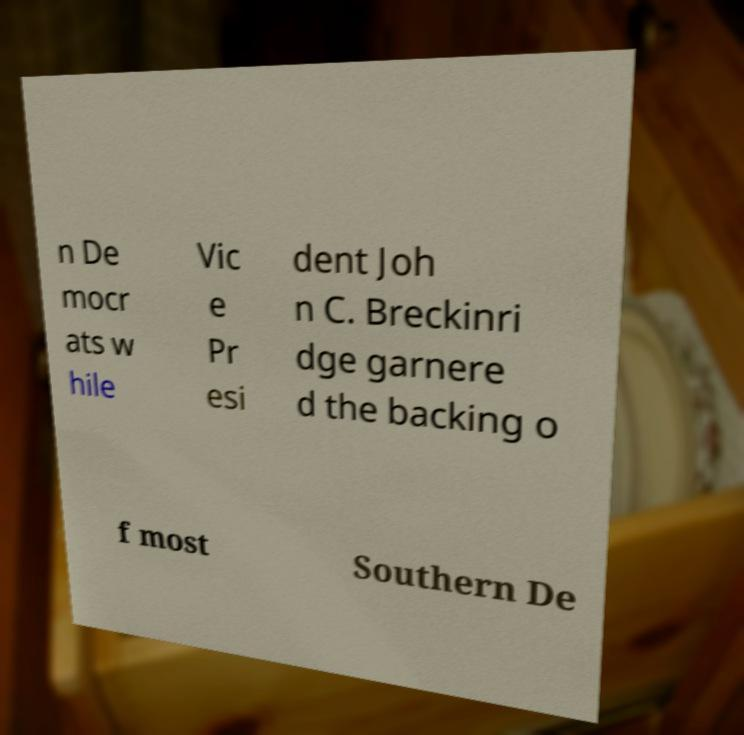What messages or text are displayed in this image? I need them in a readable, typed format. n De mocr ats w hile Vic e Pr esi dent Joh n C. Breckinri dge garnere d the backing o f most Southern De 